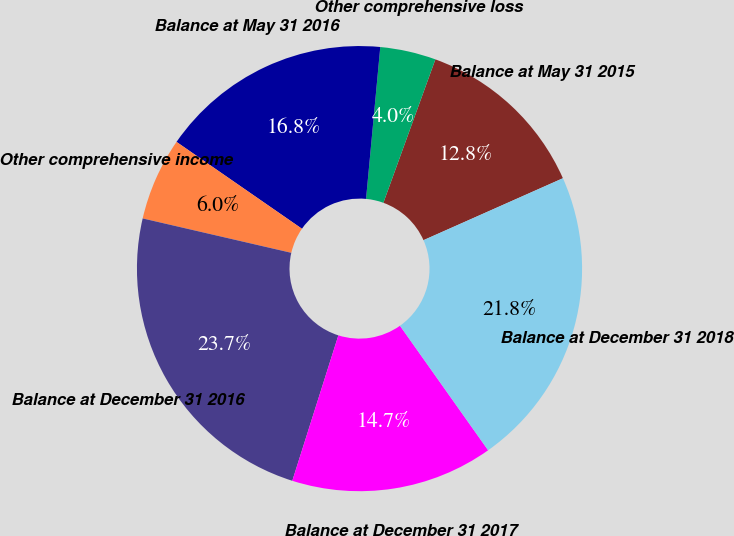Convert chart to OTSL. <chart><loc_0><loc_0><loc_500><loc_500><pie_chart><fcel>Balance at May 31 2015<fcel>Other comprehensive loss<fcel>Balance at May 31 2016<fcel>Other comprehensive income<fcel>Balance at December 31 2016<fcel>Balance at December 31 2017<fcel>Balance at December 31 2018<nl><fcel>12.81%<fcel>4.05%<fcel>16.85%<fcel>6.02%<fcel>23.74%<fcel>14.69%<fcel>21.85%<nl></chart> 